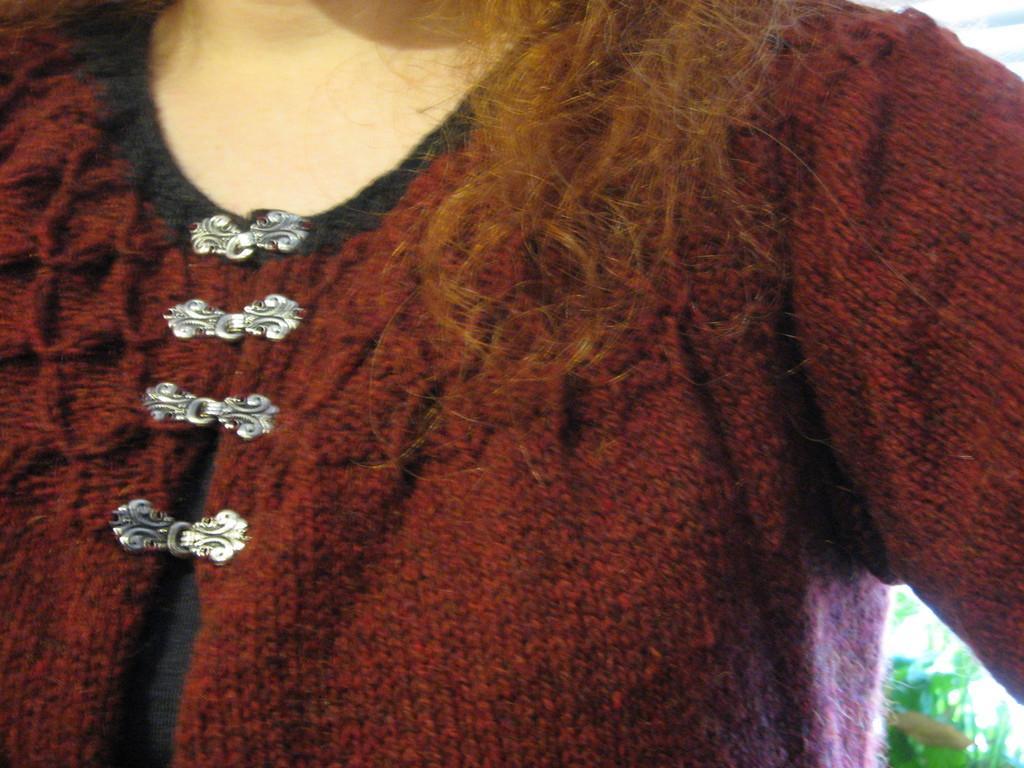In one or two sentences, can you explain what this image depicts? In this picture there is a lady in the center of the image, it seems to be there is grass in the bottom right side of the image. 